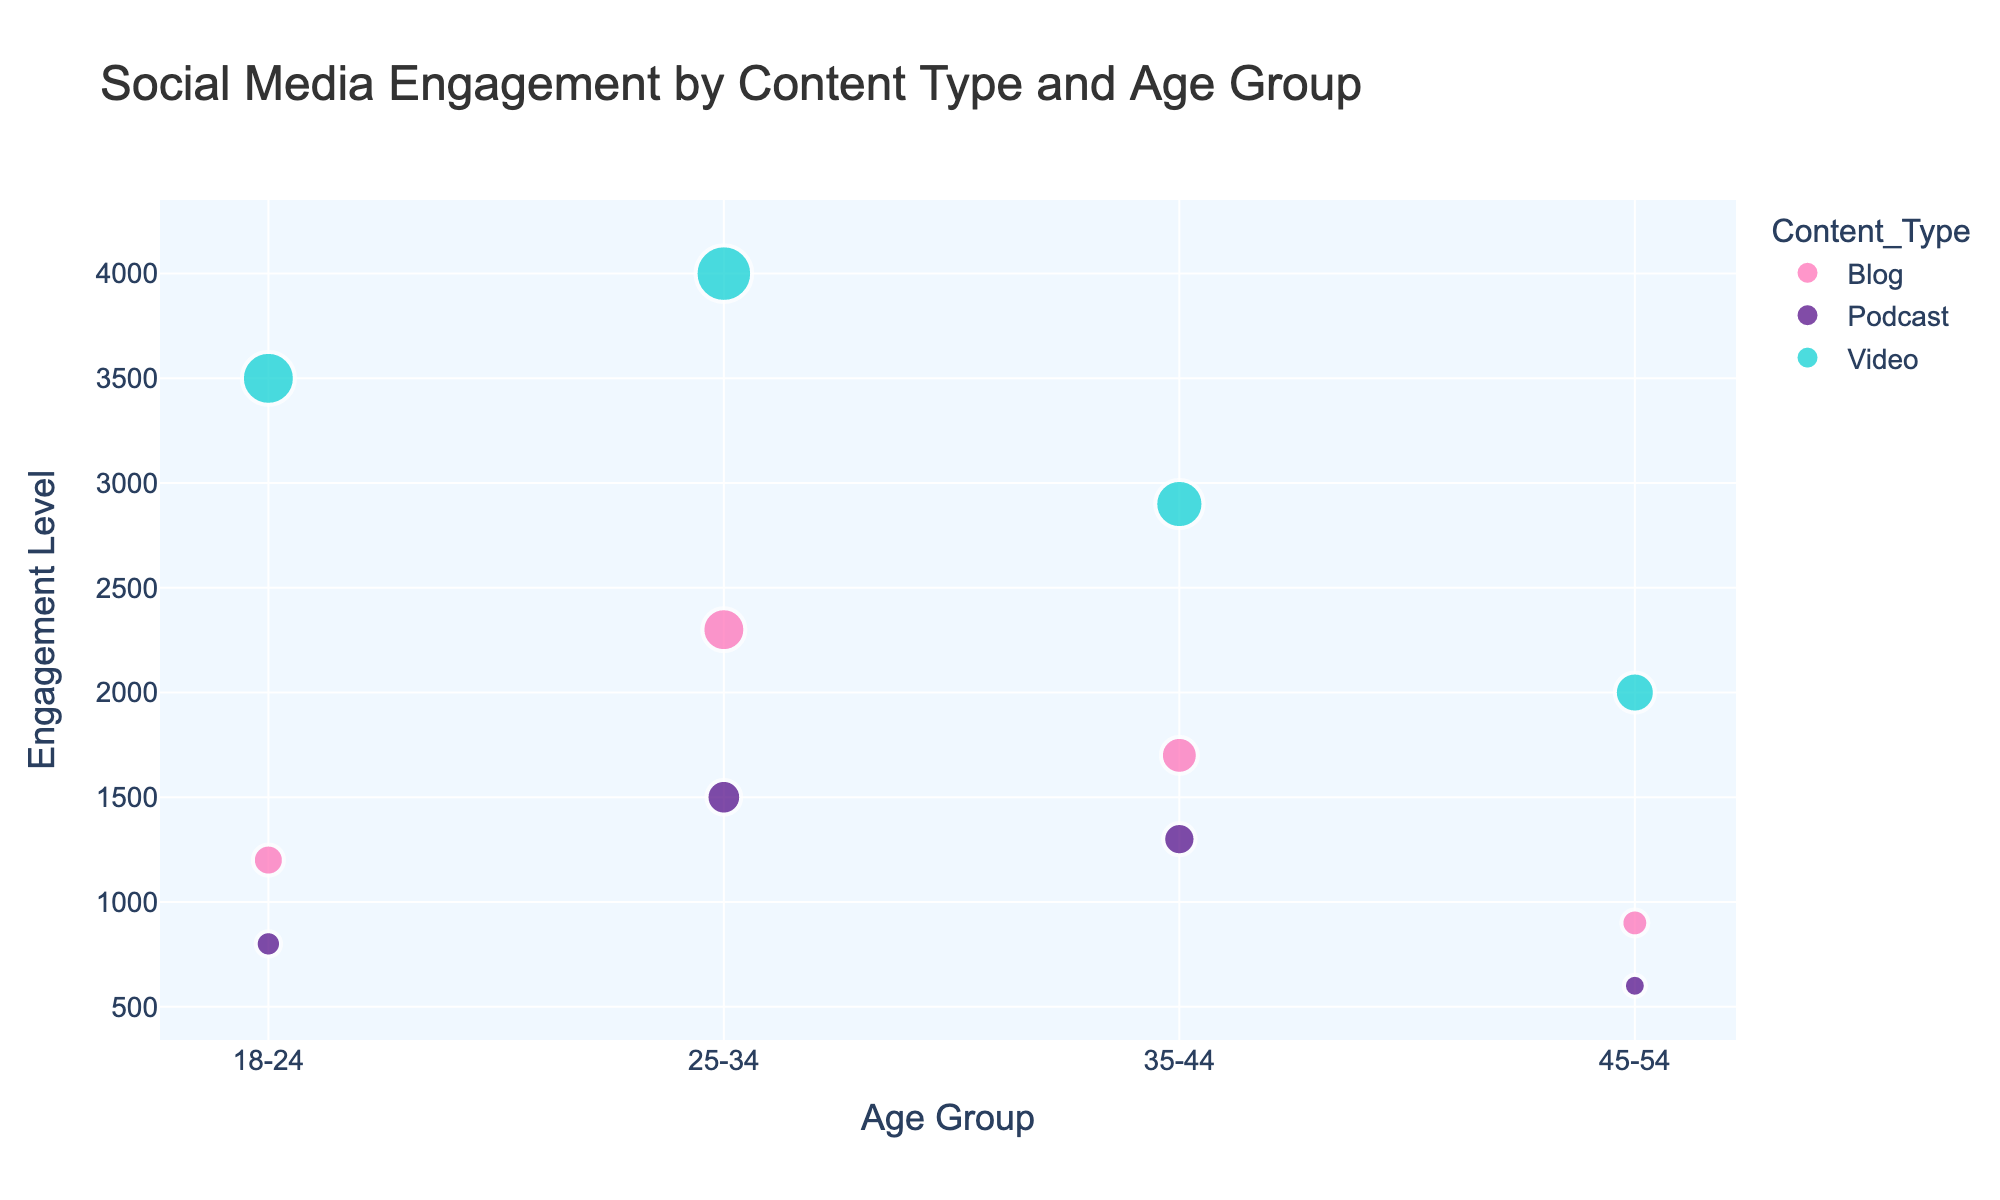What is the title of the plot? The title is displayed at the top of the plot and it reads "Social Media Engagement by Content Type and Age Group".
Answer: Social Media Engagement by Content Type and Age Group Which age group had the highest engagement level for blog content? By looking at the scatter plot and identifying the blog points which are colored pink (#FF69B4), the highest engagement level is associated with the 25-34 age group with an engagement level of 2300.
Answer: 25-34 How many data points are there for podcast content? By identifying the podcast data points, which are colored indigo (#4B0082), we count a total of 4 podcast data points on the plot.
Answer: 4 Among the different types of content, which one had the highest engagement level for the 18-24 age group? For the 18-24 age group, we compare the engagement levels of different content types. The video content, which is colored cyan (#00CED1), had the highest engagement with an engagement level of 3500.
Answer: Video What is the average engagement level for the 35-44 age group across all content types? The engagement levels in the 35-44 age group are 1700 (Blog), 1300 (Podcast), and 2900 (Video). The average engagement level is calculated as (1700 + 1300 + 2900) / 3 = 5900 / 3 = 1966.67.
Answer: 1966.67 Which content type shows the most significant drop in engagement level from the 25-34 age group to the 45-54 age group? To find the content type with the most significant drop, we compare the engagement levels for 25-34 and 45-54 age groups. Blogs: 2300 to 900 (1400 drop), Podcasts: 1500 to 600 (900 drop), and Videos: 4000 to 2000 (2000 drop). The most significant drop is in Video content with a 2000 decrease.
Answer: Video For which age group does the blog content have the least engagement? By checking the engagement level of blogs for all age groups, the least engagement is found in the 45-54 age group, which has an engagement level of 900.
Answer: 45-54 Which content type has the highest average engagement level across all age groups? We calculate the average for each content type. Blog: (1200 + 2300 + 1700 + 900) / 4 = 1525; Podcast: (800 + 1500 + 1300 + 600) / 4 = 1050; Video: (3500 + 4000 + 2900 + 2000) / 4 = 3100. The highest average engagement level is for Video content with 3100.
Answer: Video What is the total engagement level for podcasts in all age groups combined? Summing the engagement levels for podcasts in all age groups: 800 + 1500 + 1300 + 600 = 4200.
Answer: 4200 